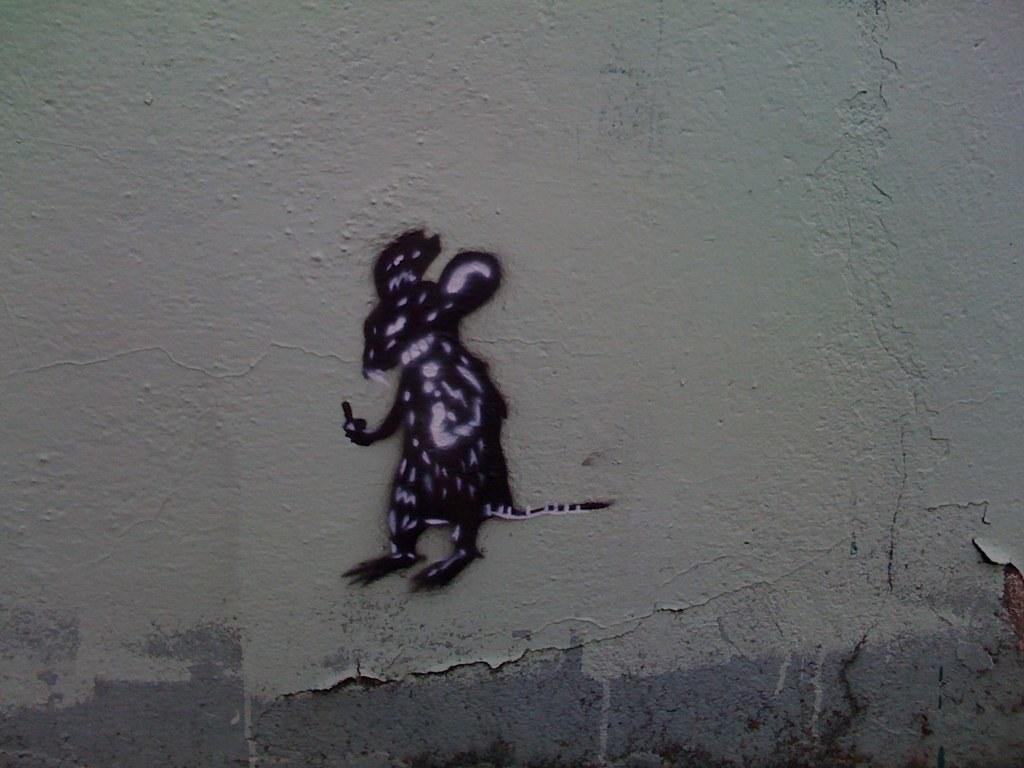Can you describe this image briefly? In this image there is a rat poster on the wall. 